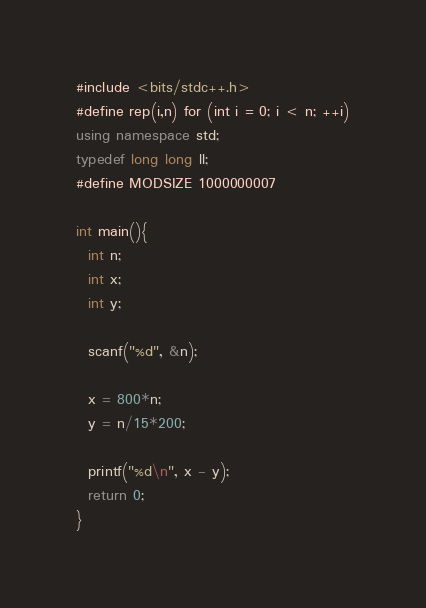Convert code to text. <code><loc_0><loc_0><loc_500><loc_500><_C++_>#include <bits/stdc++.h>
#define rep(i,n) for (int i = 0; i < n; ++i)
using namespace std;
typedef long long ll;
#define MODSIZE 1000000007

int main(){
  int n;
  int x;
  int y;

  scanf("%d", &n);

  x = 800*n;
  y = n/15*200;

  printf("%d\n", x - y);
  return 0;
}
</code> 